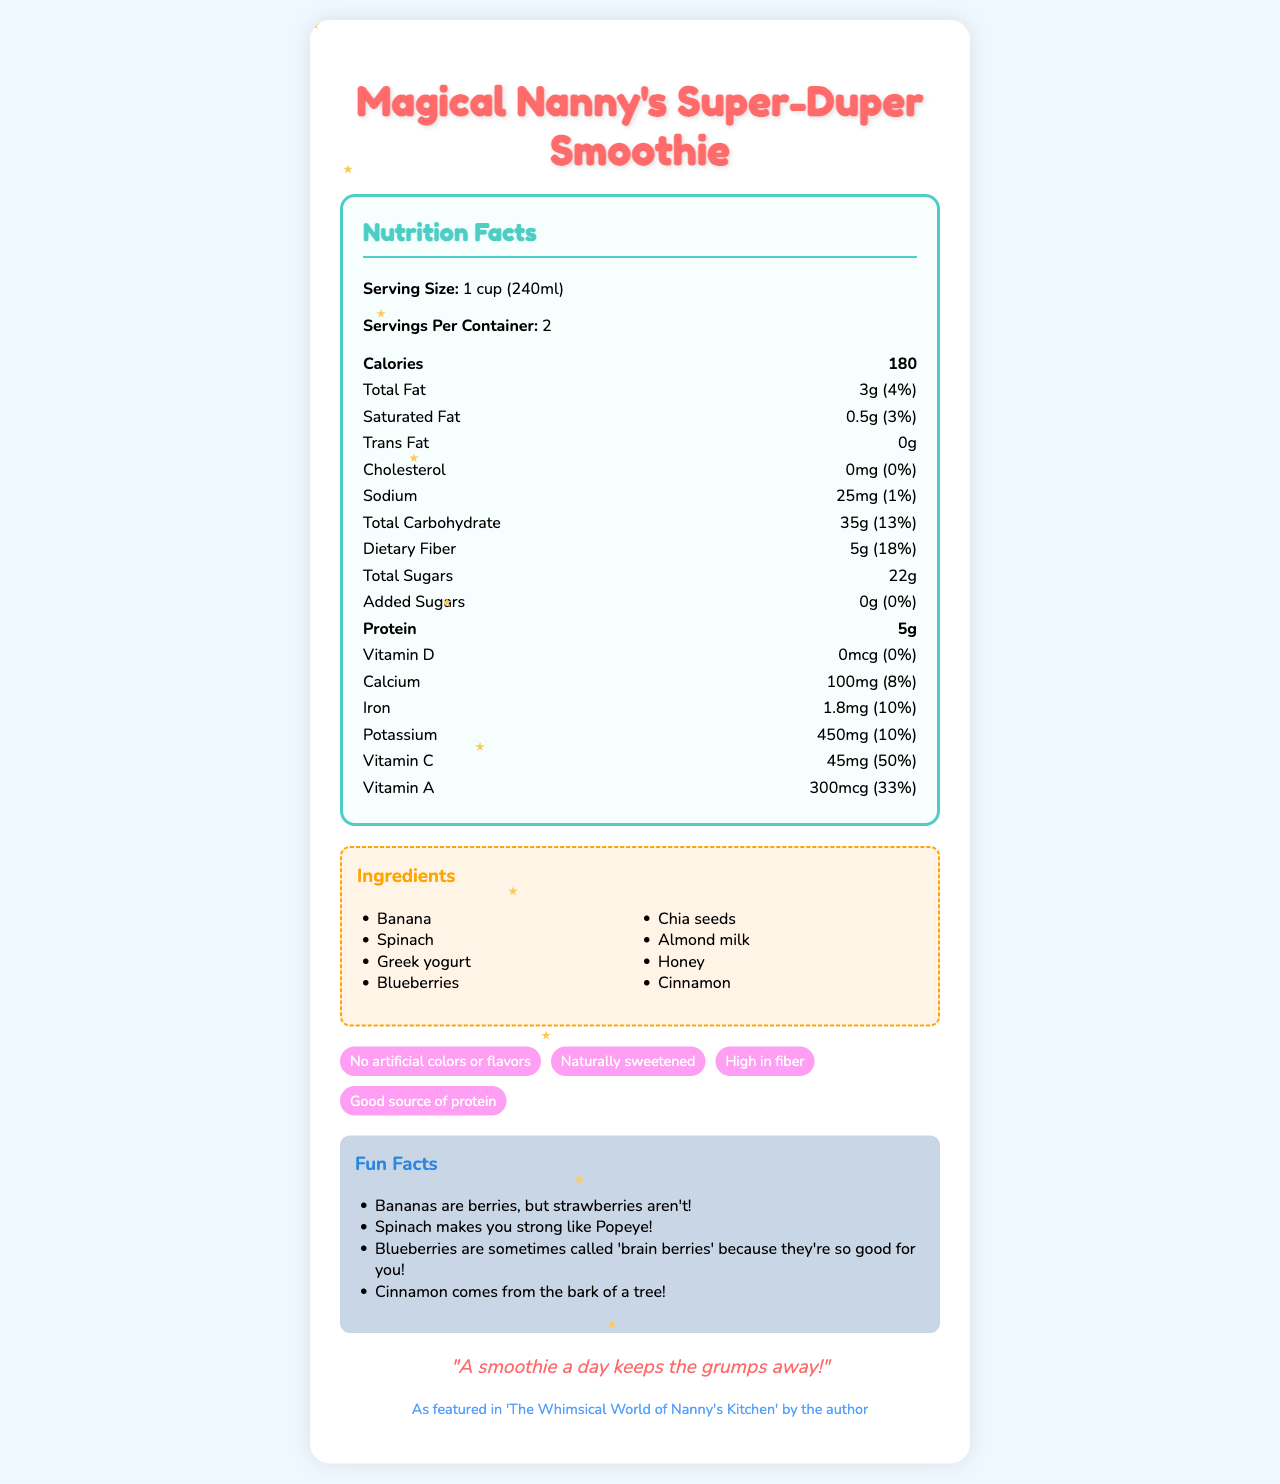what is the serving size of Magical Nanny's Super-Duper Smoothie? The serving size is clearly listed under the nutrition facts heading as "1 cup (240ml)".
Answer: 1 cup (240ml) how many calories are in one serving? The calories per serving are highlighted in bold within the nutrition facts section.
Answer: 180 what are the two main ingredients of the smoothie as listed first? The ingredients are listed in a column, with "Banana" and "Spinach" being the first two items.
Answer: Banana, Spinach which vitamin has the highest daily value percentage in this smoothie? The daily value percentage for Vitamin C is 50%, which is higher than the other listed vitamins and minerals.
Answer: Vitamin C how much dietary fiber is in one serving? The dietary fiber content is shown under the nutrition items in the nutrition facts section, with an amount of 5g.
Answer: 5g how many grams of total sugars are in this smoothie? The total sugars are listed in the nutrition facts as "22g".
Answer: 22g how many servings are in one container? The number of servings per container is listed as "2" in the nutrition facts section.
Answer: 2 which special feature is highlighted in the pink feature tag? A. High in fiber B. Good source of protein C. Naturally sweetened The special features are presented in colored tags, and the pink tag states "Naturally sweetened."
Answer: C (Naturally sweetened) what allergen information is provided on the label? The allergen information states that the product contains milk and tree nuts, specifically almonds.
Answer: Contains: Milk, Tree Nuts (Almonds) how many milligrams of potassium are in one serving? The potassium content per serving is listed as "450mg" in the nutrition facts.
Answer: 450mg this smoothie is featured in which book by the author? The book tie-in section mentions that the smoothie is featured in 'The Whimsical World of Nanny's Kitchen'.
Answer: The Whimsical World of Nanny's Kitchen does this product contain any added sugars? The added sugars are listed as 0g with a 0% daily value, indicating that there are no added sugars in the product.
Answer: No which fun fact mentions a character from popular culture? 1. Bananas are berries 2. Spinach makes you strong like Popeye 3. Blueberries are called 'brain berries' 4. Cinnamon comes from the bark of a tree The fun fact mentioning "Popeye" relates to the second option about spinach making you strong.
Answer: 2 (Spinach makes you strong like Popeye) is the nanny-approved seal present on the label? The document mentions "Mary Poppins' Seal of Approval," confirming the presence of the nanny-approved seal.
Answer: Yes summarize the main idea of the document. The document combines nutritional and promotional information while providing a whimsical, colorful design to appeal to children and adults alike. It emphasizes health benefits, natural ingredients, and fun educational elements tied to the author's book.
Answer: The document is a colorful, child-friendly nutrition label for "Magical Nanny's Super-Duper Smoothie," highlighting its serving size, nutritional content, ingredients, allergen information, special features, fun facts, and nanny wisdom, with a playful design and book tie-in reference. does this smoothie have any artificial colors or flavors? Under the special features section, it states "No artificial colors or flavors," indicating the absence of these components.
Answer: No how many grams of total fat are in one serving? The total fat content in one serving is listed as 3g in the nutrition facts.
Answer: 3g what is the color scheme used in the document? I. Sky blue II. Sunshine yellow III. Cherry red IV. Purple The listed correct color scheme components include Sky blue, Sunshine yellow, Cherry red, and Berry purple.
Answer: I, II, III, IV which nutrient has a daily value percentage greater than its corresponding amount in milligrams (mg) or micrograms (mcg)? Vitamin A has 300mcg with a 33% daily value, which is a higher percentage compared to its amount in mcg.
Answer: Vitamin A how many grams of protein are in one serving? The protein content per serving is 5g, listed in bold within the nutrition facts.
Answer: 5g which vitamin is not present in this smoothie? The nutrition facts list Vitamin D as having 0mcg and 0% daily value, indicating its absence.
Answer: Vitamin D 